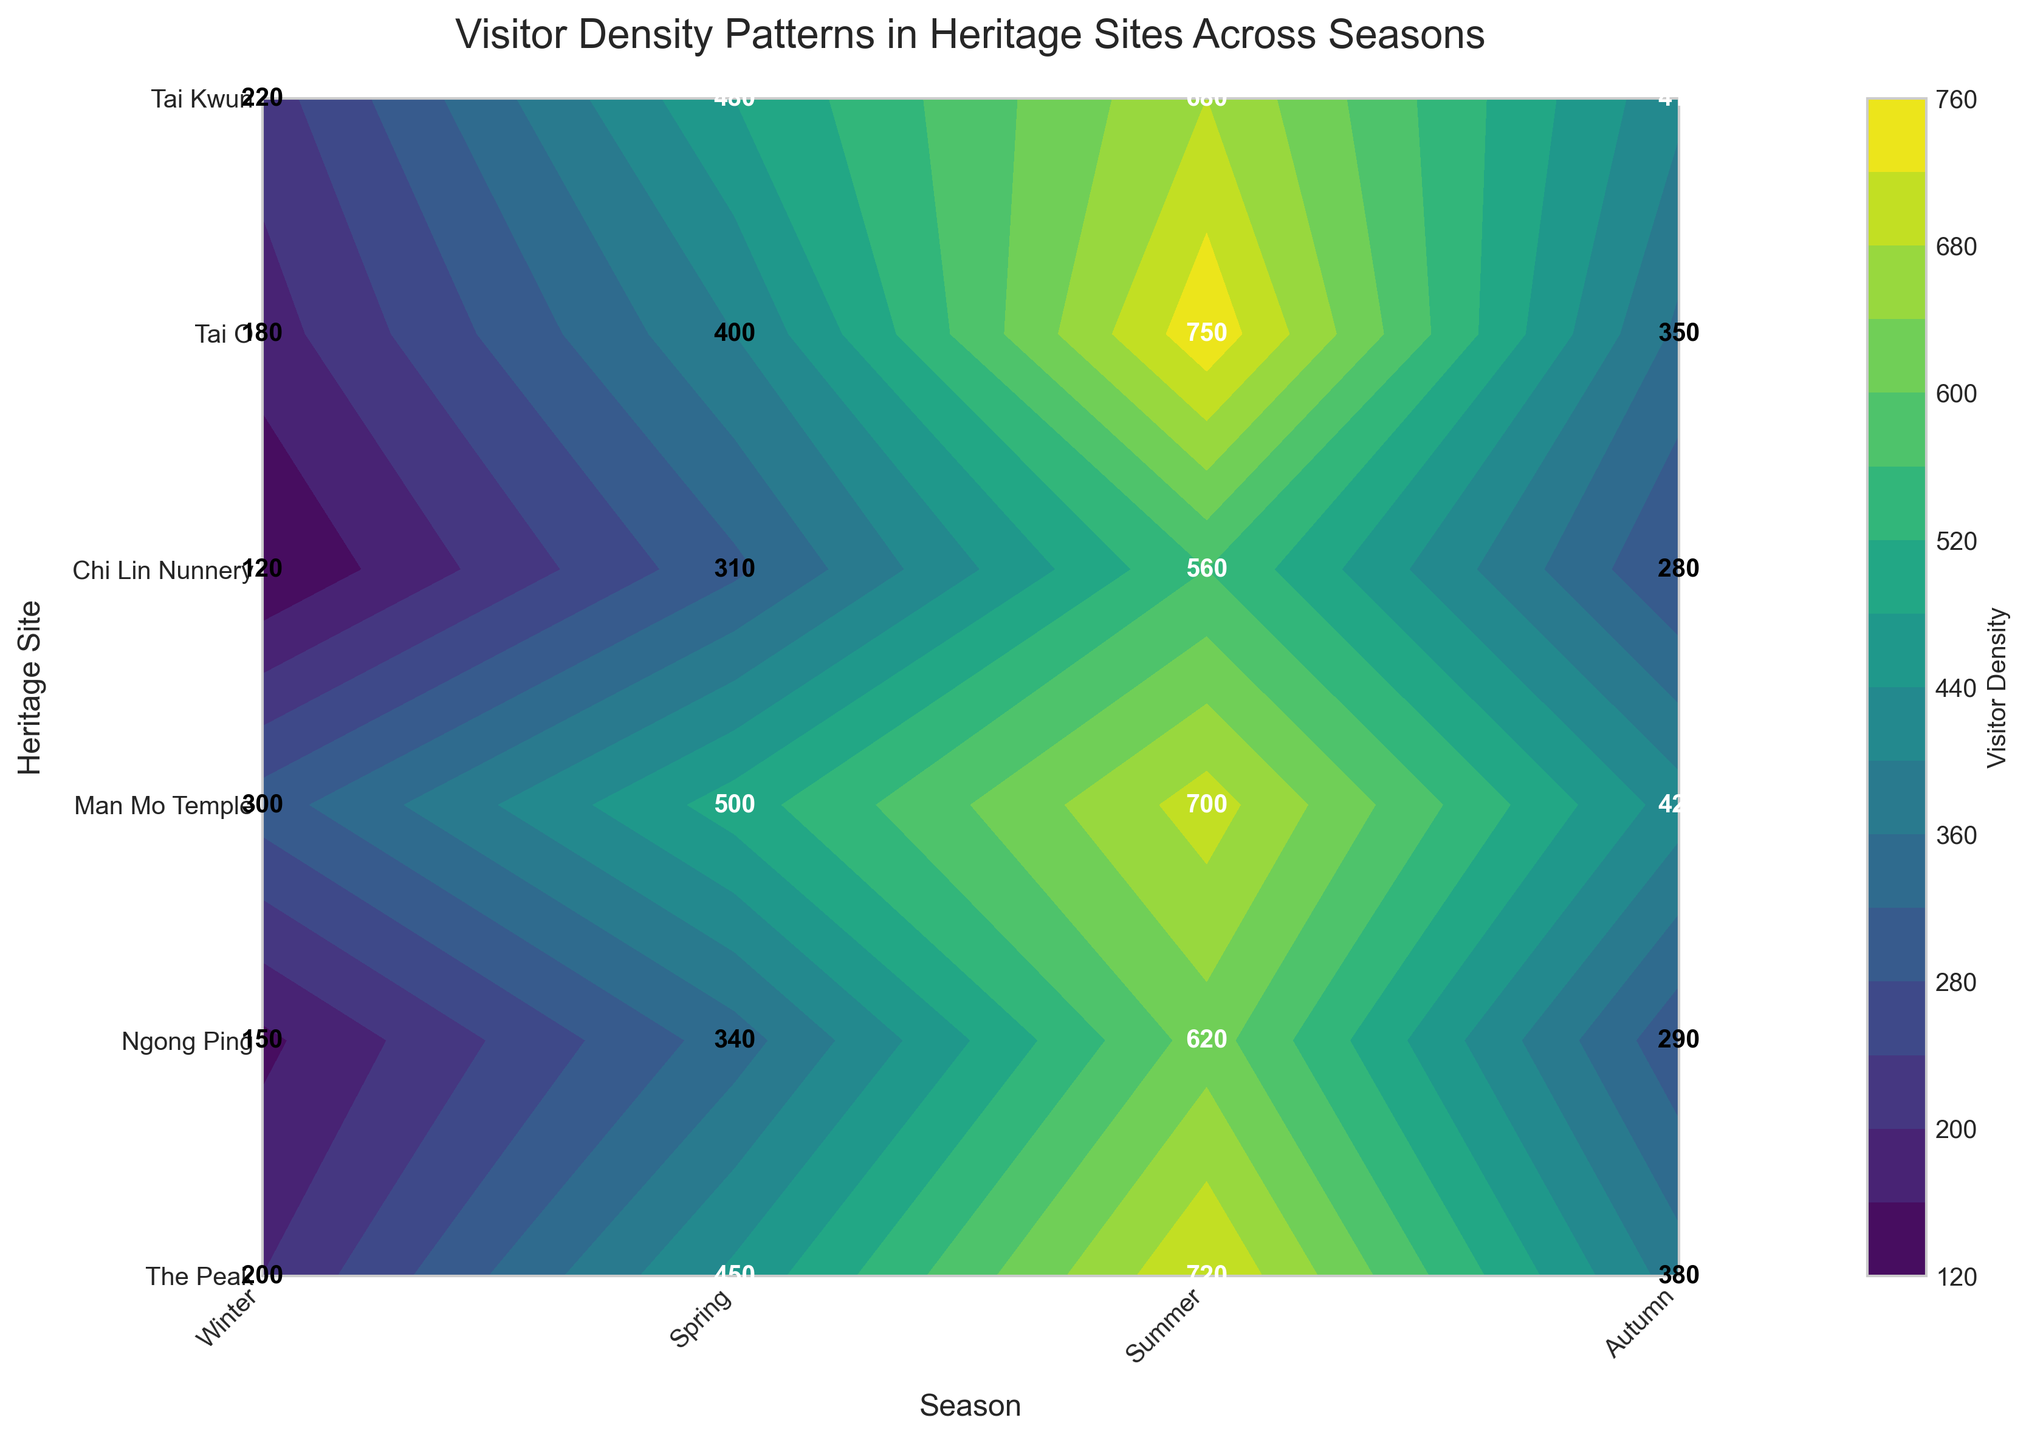What is the title of the figure? The title of a figure is typically found at the top and summarizes the content. By looking at the top of the figure, we see that the title is "Visitor Density Patterns in Heritage Sites Across Seasons."
Answer: Visitor Density Patterns in Heritage Sites Across Seasons Which heritage site has the highest visitor density in summer? To identify the heritage site with the highest visitor density in summer, locate the value in the summer column for each heritage site. The highest value is 750, which corresponds to Tai O.
Answer: Tai O What is the average visitor density at The Peak across all seasons? To find the average, sum the visitor densities for The Peak across all seasons and divide by the number of seasons. The values are 200 (Winter), 450 (Spring), 720 (Summer), and 380 (Autumn). Sum: 200 + 450 + 720 + 380 = 1750; Average: 1750 / 4 = 437.5
Answer: 437.5 Which season generally attracts the most visitors across all heritage sites? Sum the visitor densities for all heritage sites in each season and compare. Winter: 200+150+300+120+180+220=1170, Spring: 450+340+500+310+400+480=2480, Summer: 720+620+700+560+750+680=4030, Autumn: 380+290+420+280+350+410=2130. The highest sum is in Summer.
Answer: Summer What is the difference in visitor density between Chi Lin Nunnery and Man Mo Temple during autumn? Check the visitor densities for Chi Lin Nunnery (280) and Man Mo Temple (420) in Autumn. Subtract the density of Chi Lin Nunnery from Man Mo Temple: 420 - 280 = 140.
Answer: 140 Which heritage site has the most variability in visitor density across the seasons? To assess variability, look at the range or standard deviation of visitor densities for each heritage site. The Peak: 720-200=520, Ngong Ping: 620-150=470, Man Mo Temple: 700-300=400, Chi Lin Nunnery: 560-120=440, Tai O: 750-180=570, Tai Kwun: 680-220=460. Tai O shows the most variability with a range of 570.
Answer: Tai O How does the visitor density at Tai Kwun in winter compare to Ngong Ping in spring? Locate the visitor densities for Tai Kwun in Winter (220) and Ngong Ping in Spring (340), then compare them. Tai Kwun's density (220) is less than Ngong Ping's density (340).
Answer: Tai Kwun is less than Ngong Ping Which heritage site has the lowest visitor density during winter? Find the visitor densities of all heritage sites during winter. The lowest value is 120, which corresponds to Chi Lin Nunnery.
Answer: Chi Lin Nunnery What is the combined visitor density of Man Mo Temple and Tai Kwun in summer? Add the visitor densities for Man Mo Temple (700) and Tai Kwun (680) in Summer. Sum: 700 + 680 = 1380.
Answer: 1380 